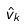Convert formula to latex. <formula><loc_0><loc_0><loc_500><loc_500>\hat { v } _ { k }</formula> 